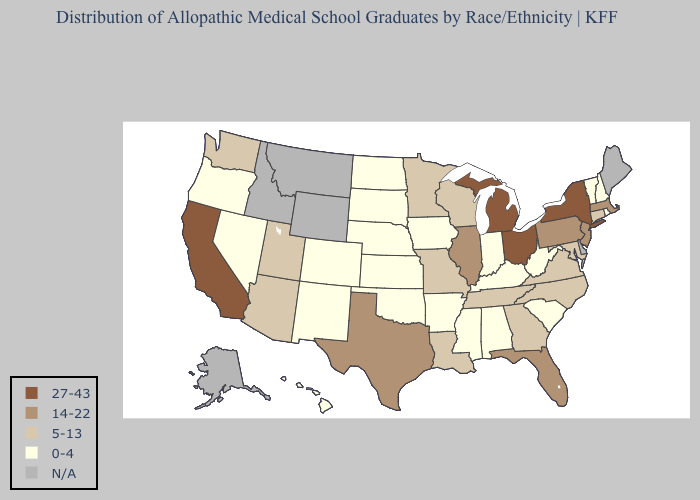What is the highest value in the Northeast ?
Give a very brief answer. 27-43. Among the states that border Texas , which have the highest value?
Keep it brief. Louisiana. What is the value of Alabama?
Answer briefly. 0-4. Name the states that have a value in the range N/A?
Short answer required. Alaska, Delaware, Idaho, Maine, Montana, Wyoming. Name the states that have a value in the range 27-43?
Write a very short answer. California, Michigan, New York, Ohio. Which states have the highest value in the USA?
Be succinct. California, Michigan, New York, Ohio. What is the value of Connecticut?
Concise answer only. 5-13. Name the states that have a value in the range 27-43?
Answer briefly. California, Michigan, New York, Ohio. How many symbols are there in the legend?
Give a very brief answer. 5. Does California have the highest value in the USA?
Write a very short answer. Yes. Is the legend a continuous bar?
Write a very short answer. No. Among the states that border Louisiana , does Arkansas have the lowest value?
Keep it brief. Yes. What is the value of Florida?
Keep it brief. 14-22. What is the lowest value in the South?
Be succinct. 0-4. 